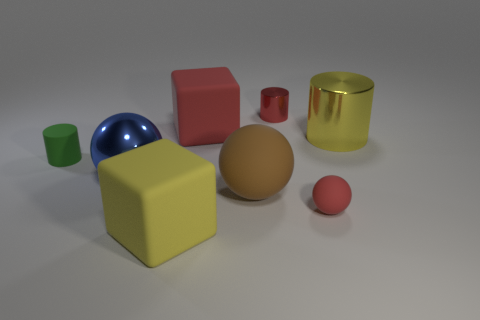Are there any yellow objects behind the large blue shiny ball?
Provide a succinct answer. Yes. Is the number of red matte objects right of the tiny red metal cylinder greater than the number of yellow metal things in front of the big yellow cube?
Provide a succinct answer. Yes. What is the size of the red matte thing that is the same shape as the yellow rubber thing?
Make the answer very short. Large. How many balls are metal things or tiny objects?
Offer a very short reply. 2. There is a small cylinder that is the same color as the small sphere; what is it made of?
Offer a terse response. Metal. Are there fewer tiny red matte things that are on the right side of the tiny ball than large yellow matte cubes that are right of the tiny green cylinder?
Offer a terse response. Yes. What number of objects are either big objects in front of the blue sphere or green matte cylinders?
Make the answer very short. 3. What shape is the tiny object that is right of the small red metallic cylinder behind the big blue shiny sphere?
Keep it short and to the point. Sphere. Is there a ball of the same size as the red metallic cylinder?
Keep it short and to the point. Yes. Are there more tiny red objects than large objects?
Your answer should be compact. No. 